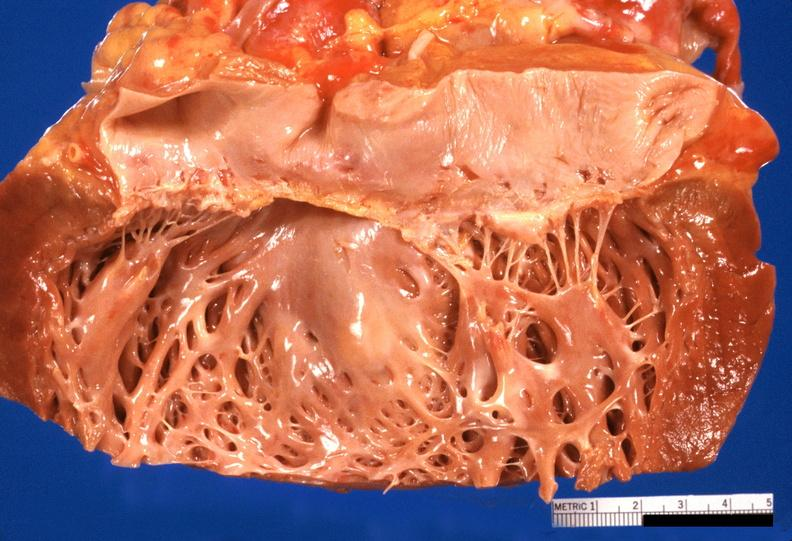s aorta present?
Answer the question using a single word or phrase. No 